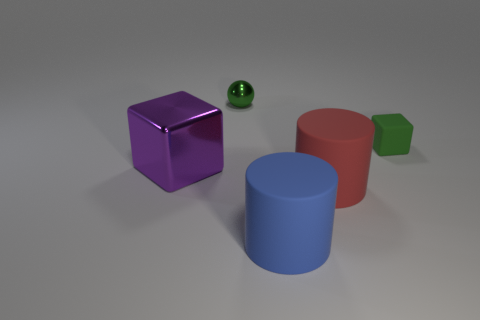What time of day does the lighting in the image suggest? The image seems to be artificially lit rather than depicting natural light. The soft shadows and the lack of a defined light source make it difficult to determine a specific time of day. It looks like a scene lit for visualization purposes without a direct correlation to time. 